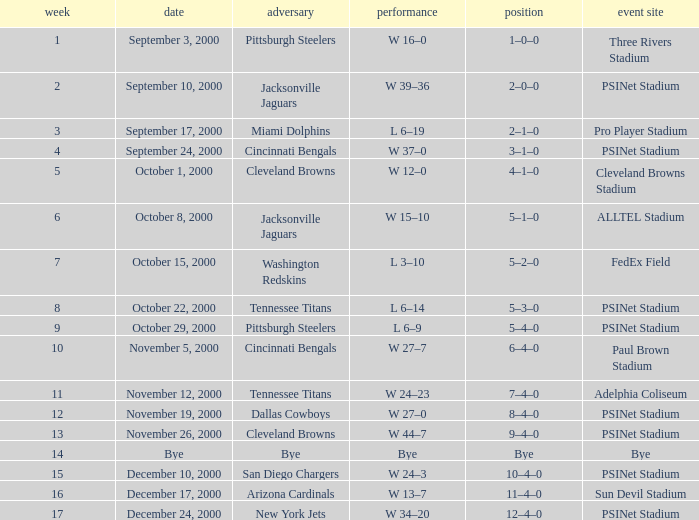Parse the table in full. {'header': ['week', 'date', 'adversary', 'performance', 'position', 'event site'], 'rows': [['1', 'September 3, 2000', 'Pittsburgh Steelers', 'W 16–0', '1–0–0', 'Three Rivers Stadium'], ['2', 'September 10, 2000', 'Jacksonville Jaguars', 'W 39–36', '2–0–0', 'PSINet Stadium'], ['3', 'September 17, 2000', 'Miami Dolphins', 'L 6–19', '2–1–0', 'Pro Player Stadium'], ['4', 'September 24, 2000', 'Cincinnati Bengals', 'W 37–0', '3–1–0', 'PSINet Stadium'], ['5', 'October 1, 2000', 'Cleveland Browns', 'W 12–0', '4–1–0', 'Cleveland Browns Stadium'], ['6', 'October 8, 2000', 'Jacksonville Jaguars', 'W 15–10', '5–1–0', 'ALLTEL Stadium'], ['7', 'October 15, 2000', 'Washington Redskins', 'L 3–10', '5–2–0', 'FedEx Field'], ['8', 'October 22, 2000', 'Tennessee Titans', 'L 6–14', '5–3–0', 'PSINet Stadium'], ['9', 'October 29, 2000', 'Pittsburgh Steelers', 'L 6–9', '5–4–0', 'PSINet Stadium'], ['10', 'November 5, 2000', 'Cincinnati Bengals', 'W 27–7', '6–4–0', 'Paul Brown Stadium'], ['11', 'November 12, 2000', 'Tennessee Titans', 'W 24–23', '7–4–0', 'Adelphia Coliseum'], ['12', 'November 19, 2000', 'Dallas Cowboys', 'W 27–0', '8–4–0', 'PSINet Stadium'], ['13', 'November 26, 2000', 'Cleveland Browns', 'W 44–7', '9–4–0', 'PSINet Stadium'], ['14', 'Bye', 'Bye', 'Bye', 'Bye', 'Bye'], ['15', 'December 10, 2000', 'San Diego Chargers', 'W 24–3', '10–4–0', 'PSINet Stadium'], ['16', 'December 17, 2000', 'Arizona Cardinals', 'W 13–7', '11–4–0', 'Sun Devil Stadium'], ['17', 'December 24, 2000', 'New York Jets', 'W 34–20', '12–4–0', 'PSINet Stadium']]} What's the record after week 16? 12–4–0. 